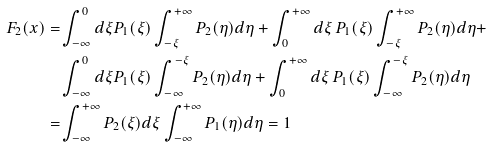Convert formula to latex. <formula><loc_0><loc_0><loc_500><loc_500>F _ { 2 } ( x ) = & \int _ { - \infty } ^ { 0 } d \xi P _ { 1 } ( \xi ) \int _ { - \xi } ^ { + \infty } P _ { 2 } ( \eta ) d \eta + \int _ { 0 } ^ { + \infty } d \xi \, P _ { 1 } ( \xi ) \int _ { - \xi } ^ { + \infty } P _ { 2 } ( \eta ) d \eta + \\ & \int _ { - \infty } ^ { 0 } d \xi P _ { 1 } ( \xi ) \int _ { - \infty } ^ { - \xi } P _ { 2 } ( \eta ) d \eta + \int _ { 0 } ^ { + \infty } d \xi \, P _ { 1 } ( \xi ) \int _ { - \infty } ^ { - \xi } P _ { 2 } ( \eta ) d \eta \\ = & \int _ { - \infty } ^ { + \infty } P _ { 2 } ( \xi ) d \xi \int _ { - \infty } ^ { + \infty } P _ { 1 } ( \eta ) d \eta = 1</formula> 